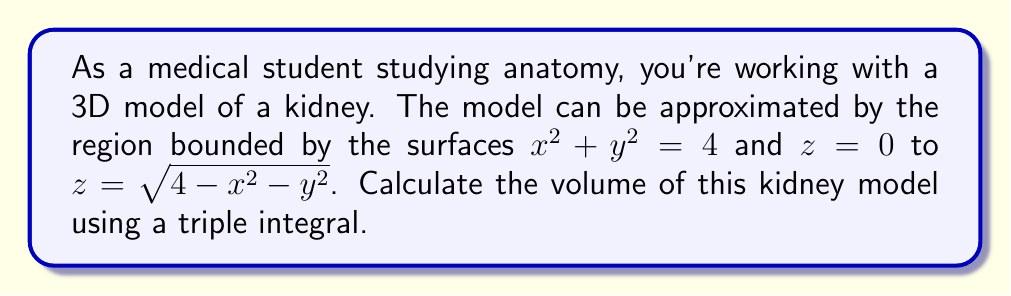Could you help me with this problem? To calculate the volume of the 3D kidney model, we need to set up and evaluate a triple integral. Let's approach this step-by-step:

1) The region is bounded by a circular cylinder $x^2 + y^2 = 4$ and extends from $z = 0$ to $z = \sqrt{4-x^2-y^2}$.

2) Due to the circular base, it's advantageous to use cylindrical coordinates:
   $x = r\cos\theta$
   $y = r\sin\theta$
   $z = z$

3) The bounds for our coordinates will be:
   $0 \leq r \leq 2$ (radius of the base circle)
   $0 \leq \theta \leq 2\pi$ (full rotation around the z-axis)
   $0 \leq z \leq \sqrt{4-r^2}$ (height varies with r)

4) The volume integral in cylindrical coordinates is:
   $$V = \int_0^{2\pi} \int_0^2 \int_0^{\sqrt{4-r^2}} r \, dz \, dr \, d\theta$$

5) Let's solve the integral from inside out:
   $$V = \int_0^{2\pi} \int_0^2 r[\sqrt{4-r^2}] \, dr \, d\theta$$

6) Now, let's solve the r integral:
   $$V = \int_0^{2\pi} \left[-\frac{1}{3}(4-r^2)^{3/2}\right]_0^2 \, d\theta$$
   $$= \int_0^{2\pi} \left[-\frac{1}{3}(0)^{3/2} + \frac{1}{3}(4)^{3/2}\right] \, d\theta$$
   $$= \int_0^{2\pi} \frac{8}{3} \, d\theta$$

7) Finally, integrate with respect to $\theta$:
   $$V = \frac{8}{3} [2\pi] = \frac{16\pi}{3}$$

Therefore, the volume of the kidney model is $\frac{16\pi}{3}$ cubic units.
Answer: $\frac{16\pi}{3}$ cubic units 